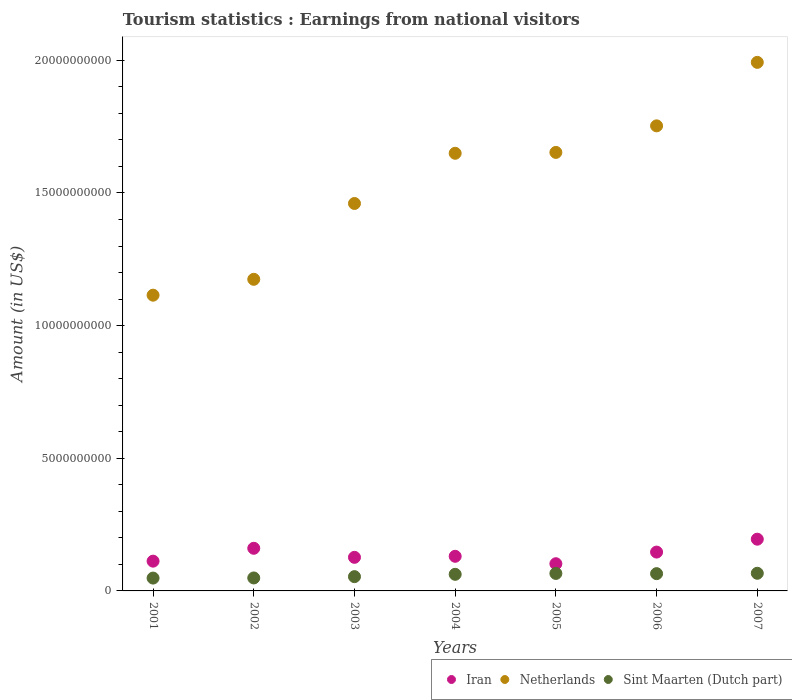How many different coloured dotlines are there?
Offer a terse response. 3. Is the number of dotlines equal to the number of legend labels?
Offer a very short reply. Yes. What is the earnings from national visitors in Iran in 2006?
Keep it short and to the point. 1.46e+09. Across all years, what is the maximum earnings from national visitors in Netherlands?
Ensure brevity in your answer.  1.99e+1. Across all years, what is the minimum earnings from national visitors in Iran?
Offer a terse response. 1.02e+09. What is the total earnings from national visitors in Netherlands in the graph?
Ensure brevity in your answer.  1.08e+11. What is the difference between the earnings from national visitors in Iran in 2001 and that in 2003?
Give a very brief answer. -1.44e+08. What is the difference between the earnings from national visitors in Sint Maarten (Dutch part) in 2005 and the earnings from national visitors in Iran in 2001?
Your answer should be very brief. -4.63e+08. What is the average earnings from national visitors in Netherlands per year?
Provide a succinct answer. 1.54e+1. In the year 2005, what is the difference between the earnings from national visitors in Sint Maarten (Dutch part) and earnings from national visitors in Iran?
Your answer should be very brief. -3.66e+08. In how many years, is the earnings from national visitors in Sint Maarten (Dutch part) greater than 5000000000 US$?
Offer a terse response. 0. What is the ratio of the earnings from national visitors in Sint Maarten (Dutch part) in 2006 to that in 2007?
Make the answer very short. 0.98. Is the earnings from national visitors in Netherlands in 2003 less than that in 2007?
Ensure brevity in your answer.  Yes. What is the difference between the highest and the lowest earnings from national visitors in Iran?
Ensure brevity in your answer.  9.25e+08. In how many years, is the earnings from national visitors in Iran greater than the average earnings from national visitors in Iran taken over all years?
Offer a very short reply. 3. Is it the case that in every year, the sum of the earnings from national visitors in Sint Maarten (Dutch part) and earnings from national visitors in Netherlands  is greater than the earnings from national visitors in Iran?
Your answer should be very brief. Yes. Does the earnings from national visitors in Sint Maarten (Dutch part) monotonically increase over the years?
Keep it short and to the point. No. Is the earnings from national visitors in Iran strictly greater than the earnings from national visitors in Netherlands over the years?
Keep it short and to the point. No. Is the earnings from national visitors in Sint Maarten (Dutch part) strictly less than the earnings from national visitors in Iran over the years?
Your answer should be very brief. Yes. How many dotlines are there?
Give a very brief answer. 3. How many years are there in the graph?
Give a very brief answer. 7. What is the difference between two consecutive major ticks on the Y-axis?
Provide a short and direct response. 5.00e+09. Are the values on the major ticks of Y-axis written in scientific E-notation?
Your answer should be very brief. No. Does the graph contain any zero values?
Offer a terse response. No. Does the graph contain grids?
Ensure brevity in your answer.  No. How many legend labels are there?
Give a very brief answer. 3. How are the legend labels stacked?
Give a very brief answer. Horizontal. What is the title of the graph?
Offer a very short reply. Tourism statistics : Earnings from national visitors. What is the label or title of the X-axis?
Your answer should be compact. Years. What is the Amount (in US$) in Iran in 2001?
Your response must be concise. 1.12e+09. What is the Amount (in US$) of Netherlands in 2001?
Your answer should be very brief. 1.11e+1. What is the Amount (in US$) in Sint Maarten (Dutch part) in 2001?
Your answer should be very brief. 4.84e+08. What is the Amount (in US$) in Iran in 2002?
Offer a very short reply. 1.61e+09. What is the Amount (in US$) in Netherlands in 2002?
Your answer should be compact. 1.17e+1. What is the Amount (in US$) of Sint Maarten (Dutch part) in 2002?
Your response must be concise. 4.89e+08. What is the Amount (in US$) of Iran in 2003?
Offer a terse response. 1.27e+09. What is the Amount (in US$) in Netherlands in 2003?
Give a very brief answer. 1.46e+1. What is the Amount (in US$) in Sint Maarten (Dutch part) in 2003?
Make the answer very short. 5.38e+08. What is the Amount (in US$) of Iran in 2004?
Your response must be concise. 1.30e+09. What is the Amount (in US$) in Netherlands in 2004?
Your response must be concise. 1.65e+1. What is the Amount (in US$) in Sint Maarten (Dutch part) in 2004?
Your response must be concise. 6.26e+08. What is the Amount (in US$) of Iran in 2005?
Keep it short and to the point. 1.02e+09. What is the Amount (in US$) of Netherlands in 2005?
Your response must be concise. 1.65e+1. What is the Amount (in US$) of Sint Maarten (Dutch part) in 2005?
Your answer should be very brief. 6.59e+08. What is the Amount (in US$) in Iran in 2006?
Ensure brevity in your answer.  1.46e+09. What is the Amount (in US$) in Netherlands in 2006?
Keep it short and to the point. 1.75e+1. What is the Amount (in US$) of Sint Maarten (Dutch part) in 2006?
Give a very brief answer. 6.51e+08. What is the Amount (in US$) in Iran in 2007?
Your answer should be compact. 1.95e+09. What is the Amount (in US$) of Netherlands in 2007?
Your answer should be compact. 1.99e+1. What is the Amount (in US$) of Sint Maarten (Dutch part) in 2007?
Keep it short and to the point. 6.65e+08. Across all years, what is the maximum Amount (in US$) of Iran?
Ensure brevity in your answer.  1.95e+09. Across all years, what is the maximum Amount (in US$) in Netherlands?
Your response must be concise. 1.99e+1. Across all years, what is the maximum Amount (in US$) of Sint Maarten (Dutch part)?
Keep it short and to the point. 6.65e+08. Across all years, what is the minimum Amount (in US$) of Iran?
Your response must be concise. 1.02e+09. Across all years, what is the minimum Amount (in US$) in Netherlands?
Make the answer very short. 1.11e+1. Across all years, what is the minimum Amount (in US$) of Sint Maarten (Dutch part)?
Keep it short and to the point. 4.84e+08. What is the total Amount (in US$) of Iran in the graph?
Give a very brief answer. 9.74e+09. What is the total Amount (in US$) in Netherlands in the graph?
Give a very brief answer. 1.08e+11. What is the total Amount (in US$) of Sint Maarten (Dutch part) in the graph?
Offer a terse response. 4.11e+09. What is the difference between the Amount (in US$) of Iran in 2001 and that in 2002?
Make the answer very short. -4.85e+08. What is the difference between the Amount (in US$) of Netherlands in 2001 and that in 2002?
Your answer should be very brief. -5.98e+08. What is the difference between the Amount (in US$) of Sint Maarten (Dutch part) in 2001 and that in 2002?
Keep it short and to the point. -5.00e+06. What is the difference between the Amount (in US$) of Iran in 2001 and that in 2003?
Give a very brief answer. -1.44e+08. What is the difference between the Amount (in US$) of Netherlands in 2001 and that in 2003?
Offer a very short reply. -3.46e+09. What is the difference between the Amount (in US$) in Sint Maarten (Dutch part) in 2001 and that in 2003?
Make the answer very short. -5.40e+07. What is the difference between the Amount (in US$) of Iran in 2001 and that in 2004?
Your response must be concise. -1.83e+08. What is the difference between the Amount (in US$) in Netherlands in 2001 and that in 2004?
Your answer should be very brief. -5.35e+09. What is the difference between the Amount (in US$) in Sint Maarten (Dutch part) in 2001 and that in 2004?
Make the answer very short. -1.42e+08. What is the difference between the Amount (in US$) of Iran in 2001 and that in 2005?
Offer a terse response. 9.70e+07. What is the difference between the Amount (in US$) in Netherlands in 2001 and that in 2005?
Your answer should be very brief. -5.38e+09. What is the difference between the Amount (in US$) of Sint Maarten (Dutch part) in 2001 and that in 2005?
Provide a succinct answer. -1.75e+08. What is the difference between the Amount (in US$) of Iran in 2001 and that in 2006?
Offer a very short reply. -3.42e+08. What is the difference between the Amount (in US$) of Netherlands in 2001 and that in 2006?
Your answer should be very brief. -6.38e+09. What is the difference between the Amount (in US$) in Sint Maarten (Dutch part) in 2001 and that in 2006?
Your answer should be very brief. -1.67e+08. What is the difference between the Amount (in US$) of Iran in 2001 and that in 2007?
Ensure brevity in your answer.  -8.28e+08. What is the difference between the Amount (in US$) in Netherlands in 2001 and that in 2007?
Your answer should be very brief. -8.78e+09. What is the difference between the Amount (in US$) of Sint Maarten (Dutch part) in 2001 and that in 2007?
Provide a succinct answer. -1.81e+08. What is the difference between the Amount (in US$) in Iran in 2002 and that in 2003?
Provide a short and direct response. 3.41e+08. What is the difference between the Amount (in US$) of Netherlands in 2002 and that in 2003?
Offer a terse response. -2.86e+09. What is the difference between the Amount (in US$) of Sint Maarten (Dutch part) in 2002 and that in 2003?
Your answer should be very brief. -4.90e+07. What is the difference between the Amount (in US$) of Iran in 2002 and that in 2004?
Your answer should be very brief. 3.02e+08. What is the difference between the Amount (in US$) in Netherlands in 2002 and that in 2004?
Make the answer very short. -4.75e+09. What is the difference between the Amount (in US$) of Sint Maarten (Dutch part) in 2002 and that in 2004?
Your answer should be compact. -1.37e+08. What is the difference between the Amount (in US$) of Iran in 2002 and that in 2005?
Provide a short and direct response. 5.82e+08. What is the difference between the Amount (in US$) in Netherlands in 2002 and that in 2005?
Provide a short and direct response. -4.78e+09. What is the difference between the Amount (in US$) in Sint Maarten (Dutch part) in 2002 and that in 2005?
Your answer should be very brief. -1.70e+08. What is the difference between the Amount (in US$) of Iran in 2002 and that in 2006?
Provide a short and direct response. 1.43e+08. What is the difference between the Amount (in US$) in Netherlands in 2002 and that in 2006?
Ensure brevity in your answer.  -5.78e+09. What is the difference between the Amount (in US$) in Sint Maarten (Dutch part) in 2002 and that in 2006?
Your answer should be compact. -1.62e+08. What is the difference between the Amount (in US$) in Iran in 2002 and that in 2007?
Keep it short and to the point. -3.43e+08. What is the difference between the Amount (in US$) in Netherlands in 2002 and that in 2007?
Ensure brevity in your answer.  -8.18e+09. What is the difference between the Amount (in US$) of Sint Maarten (Dutch part) in 2002 and that in 2007?
Offer a terse response. -1.76e+08. What is the difference between the Amount (in US$) in Iran in 2003 and that in 2004?
Offer a very short reply. -3.90e+07. What is the difference between the Amount (in US$) in Netherlands in 2003 and that in 2004?
Give a very brief answer. -1.89e+09. What is the difference between the Amount (in US$) in Sint Maarten (Dutch part) in 2003 and that in 2004?
Keep it short and to the point. -8.80e+07. What is the difference between the Amount (in US$) of Iran in 2003 and that in 2005?
Your answer should be very brief. 2.41e+08. What is the difference between the Amount (in US$) of Netherlands in 2003 and that in 2005?
Make the answer very short. -1.92e+09. What is the difference between the Amount (in US$) of Sint Maarten (Dutch part) in 2003 and that in 2005?
Provide a succinct answer. -1.21e+08. What is the difference between the Amount (in US$) in Iran in 2003 and that in 2006?
Your response must be concise. -1.98e+08. What is the difference between the Amount (in US$) in Netherlands in 2003 and that in 2006?
Provide a succinct answer. -2.93e+09. What is the difference between the Amount (in US$) of Sint Maarten (Dutch part) in 2003 and that in 2006?
Give a very brief answer. -1.13e+08. What is the difference between the Amount (in US$) of Iran in 2003 and that in 2007?
Your answer should be compact. -6.84e+08. What is the difference between the Amount (in US$) of Netherlands in 2003 and that in 2007?
Your answer should be very brief. -5.32e+09. What is the difference between the Amount (in US$) of Sint Maarten (Dutch part) in 2003 and that in 2007?
Offer a very short reply. -1.27e+08. What is the difference between the Amount (in US$) of Iran in 2004 and that in 2005?
Your answer should be compact. 2.80e+08. What is the difference between the Amount (in US$) in Netherlands in 2004 and that in 2005?
Make the answer very short. -3.30e+07. What is the difference between the Amount (in US$) in Sint Maarten (Dutch part) in 2004 and that in 2005?
Your response must be concise. -3.30e+07. What is the difference between the Amount (in US$) in Iran in 2004 and that in 2006?
Your response must be concise. -1.59e+08. What is the difference between the Amount (in US$) of Netherlands in 2004 and that in 2006?
Ensure brevity in your answer.  -1.03e+09. What is the difference between the Amount (in US$) of Sint Maarten (Dutch part) in 2004 and that in 2006?
Offer a terse response. -2.50e+07. What is the difference between the Amount (in US$) of Iran in 2004 and that in 2007?
Your answer should be very brief. -6.45e+08. What is the difference between the Amount (in US$) in Netherlands in 2004 and that in 2007?
Offer a very short reply. -3.43e+09. What is the difference between the Amount (in US$) in Sint Maarten (Dutch part) in 2004 and that in 2007?
Make the answer very short. -3.90e+07. What is the difference between the Amount (in US$) of Iran in 2005 and that in 2006?
Offer a very short reply. -4.39e+08. What is the difference between the Amount (in US$) in Netherlands in 2005 and that in 2006?
Your answer should be compact. -1.00e+09. What is the difference between the Amount (in US$) of Iran in 2005 and that in 2007?
Keep it short and to the point. -9.25e+08. What is the difference between the Amount (in US$) of Netherlands in 2005 and that in 2007?
Provide a short and direct response. -3.39e+09. What is the difference between the Amount (in US$) in Sint Maarten (Dutch part) in 2005 and that in 2007?
Your response must be concise. -6.00e+06. What is the difference between the Amount (in US$) in Iran in 2006 and that in 2007?
Provide a short and direct response. -4.86e+08. What is the difference between the Amount (in US$) of Netherlands in 2006 and that in 2007?
Make the answer very short. -2.39e+09. What is the difference between the Amount (in US$) in Sint Maarten (Dutch part) in 2006 and that in 2007?
Ensure brevity in your answer.  -1.40e+07. What is the difference between the Amount (in US$) of Iran in 2001 and the Amount (in US$) of Netherlands in 2002?
Provide a short and direct response. -1.06e+1. What is the difference between the Amount (in US$) in Iran in 2001 and the Amount (in US$) in Sint Maarten (Dutch part) in 2002?
Offer a terse response. 6.33e+08. What is the difference between the Amount (in US$) of Netherlands in 2001 and the Amount (in US$) of Sint Maarten (Dutch part) in 2002?
Offer a terse response. 1.07e+1. What is the difference between the Amount (in US$) of Iran in 2001 and the Amount (in US$) of Netherlands in 2003?
Your answer should be compact. -1.35e+1. What is the difference between the Amount (in US$) of Iran in 2001 and the Amount (in US$) of Sint Maarten (Dutch part) in 2003?
Offer a terse response. 5.84e+08. What is the difference between the Amount (in US$) of Netherlands in 2001 and the Amount (in US$) of Sint Maarten (Dutch part) in 2003?
Provide a succinct answer. 1.06e+1. What is the difference between the Amount (in US$) of Iran in 2001 and the Amount (in US$) of Netherlands in 2004?
Offer a terse response. -1.54e+1. What is the difference between the Amount (in US$) in Iran in 2001 and the Amount (in US$) in Sint Maarten (Dutch part) in 2004?
Provide a succinct answer. 4.96e+08. What is the difference between the Amount (in US$) in Netherlands in 2001 and the Amount (in US$) in Sint Maarten (Dutch part) in 2004?
Give a very brief answer. 1.05e+1. What is the difference between the Amount (in US$) in Iran in 2001 and the Amount (in US$) in Netherlands in 2005?
Keep it short and to the point. -1.54e+1. What is the difference between the Amount (in US$) of Iran in 2001 and the Amount (in US$) of Sint Maarten (Dutch part) in 2005?
Ensure brevity in your answer.  4.63e+08. What is the difference between the Amount (in US$) in Netherlands in 2001 and the Amount (in US$) in Sint Maarten (Dutch part) in 2005?
Your answer should be very brief. 1.05e+1. What is the difference between the Amount (in US$) in Iran in 2001 and the Amount (in US$) in Netherlands in 2006?
Your response must be concise. -1.64e+1. What is the difference between the Amount (in US$) in Iran in 2001 and the Amount (in US$) in Sint Maarten (Dutch part) in 2006?
Offer a terse response. 4.71e+08. What is the difference between the Amount (in US$) of Netherlands in 2001 and the Amount (in US$) of Sint Maarten (Dutch part) in 2006?
Provide a short and direct response. 1.05e+1. What is the difference between the Amount (in US$) of Iran in 2001 and the Amount (in US$) of Netherlands in 2007?
Your response must be concise. -1.88e+1. What is the difference between the Amount (in US$) in Iran in 2001 and the Amount (in US$) in Sint Maarten (Dutch part) in 2007?
Your response must be concise. 4.57e+08. What is the difference between the Amount (in US$) of Netherlands in 2001 and the Amount (in US$) of Sint Maarten (Dutch part) in 2007?
Offer a terse response. 1.05e+1. What is the difference between the Amount (in US$) of Iran in 2002 and the Amount (in US$) of Netherlands in 2003?
Provide a short and direct response. -1.30e+1. What is the difference between the Amount (in US$) in Iran in 2002 and the Amount (in US$) in Sint Maarten (Dutch part) in 2003?
Offer a very short reply. 1.07e+09. What is the difference between the Amount (in US$) in Netherlands in 2002 and the Amount (in US$) in Sint Maarten (Dutch part) in 2003?
Ensure brevity in your answer.  1.12e+1. What is the difference between the Amount (in US$) of Iran in 2002 and the Amount (in US$) of Netherlands in 2004?
Your answer should be very brief. -1.49e+1. What is the difference between the Amount (in US$) in Iran in 2002 and the Amount (in US$) in Sint Maarten (Dutch part) in 2004?
Give a very brief answer. 9.81e+08. What is the difference between the Amount (in US$) in Netherlands in 2002 and the Amount (in US$) in Sint Maarten (Dutch part) in 2004?
Ensure brevity in your answer.  1.11e+1. What is the difference between the Amount (in US$) in Iran in 2002 and the Amount (in US$) in Netherlands in 2005?
Provide a short and direct response. -1.49e+1. What is the difference between the Amount (in US$) in Iran in 2002 and the Amount (in US$) in Sint Maarten (Dutch part) in 2005?
Your answer should be very brief. 9.48e+08. What is the difference between the Amount (in US$) of Netherlands in 2002 and the Amount (in US$) of Sint Maarten (Dutch part) in 2005?
Your answer should be very brief. 1.11e+1. What is the difference between the Amount (in US$) of Iran in 2002 and the Amount (in US$) of Netherlands in 2006?
Offer a terse response. -1.59e+1. What is the difference between the Amount (in US$) in Iran in 2002 and the Amount (in US$) in Sint Maarten (Dutch part) in 2006?
Keep it short and to the point. 9.56e+08. What is the difference between the Amount (in US$) in Netherlands in 2002 and the Amount (in US$) in Sint Maarten (Dutch part) in 2006?
Offer a very short reply. 1.11e+1. What is the difference between the Amount (in US$) of Iran in 2002 and the Amount (in US$) of Netherlands in 2007?
Your answer should be compact. -1.83e+1. What is the difference between the Amount (in US$) in Iran in 2002 and the Amount (in US$) in Sint Maarten (Dutch part) in 2007?
Your answer should be compact. 9.42e+08. What is the difference between the Amount (in US$) of Netherlands in 2002 and the Amount (in US$) of Sint Maarten (Dutch part) in 2007?
Offer a terse response. 1.11e+1. What is the difference between the Amount (in US$) of Iran in 2003 and the Amount (in US$) of Netherlands in 2004?
Your answer should be very brief. -1.52e+1. What is the difference between the Amount (in US$) in Iran in 2003 and the Amount (in US$) in Sint Maarten (Dutch part) in 2004?
Your response must be concise. 6.40e+08. What is the difference between the Amount (in US$) of Netherlands in 2003 and the Amount (in US$) of Sint Maarten (Dutch part) in 2004?
Make the answer very short. 1.40e+1. What is the difference between the Amount (in US$) of Iran in 2003 and the Amount (in US$) of Netherlands in 2005?
Provide a short and direct response. -1.53e+1. What is the difference between the Amount (in US$) in Iran in 2003 and the Amount (in US$) in Sint Maarten (Dutch part) in 2005?
Your answer should be very brief. 6.07e+08. What is the difference between the Amount (in US$) of Netherlands in 2003 and the Amount (in US$) of Sint Maarten (Dutch part) in 2005?
Your response must be concise. 1.39e+1. What is the difference between the Amount (in US$) of Iran in 2003 and the Amount (in US$) of Netherlands in 2006?
Your answer should be compact. -1.63e+1. What is the difference between the Amount (in US$) in Iran in 2003 and the Amount (in US$) in Sint Maarten (Dutch part) in 2006?
Your answer should be very brief. 6.15e+08. What is the difference between the Amount (in US$) in Netherlands in 2003 and the Amount (in US$) in Sint Maarten (Dutch part) in 2006?
Offer a very short reply. 1.40e+1. What is the difference between the Amount (in US$) of Iran in 2003 and the Amount (in US$) of Netherlands in 2007?
Make the answer very short. -1.87e+1. What is the difference between the Amount (in US$) of Iran in 2003 and the Amount (in US$) of Sint Maarten (Dutch part) in 2007?
Give a very brief answer. 6.01e+08. What is the difference between the Amount (in US$) in Netherlands in 2003 and the Amount (in US$) in Sint Maarten (Dutch part) in 2007?
Give a very brief answer. 1.39e+1. What is the difference between the Amount (in US$) in Iran in 2004 and the Amount (in US$) in Netherlands in 2005?
Your answer should be very brief. -1.52e+1. What is the difference between the Amount (in US$) of Iran in 2004 and the Amount (in US$) of Sint Maarten (Dutch part) in 2005?
Provide a succinct answer. 6.46e+08. What is the difference between the Amount (in US$) in Netherlands in 2004 and the Amount (in US$) in Sint Maarten (Dutch part) in 2005?
Your answer should be compact. 1.58e+1. What is the difference between the Amount (in US$) of Iran in 2004 and the Amount (in US$) of Netherlands in 2006?
Your answer should be compact. -1.62e+1. What is the difference between the Amount (in US$) of Iran in 2004 and the Amount (in US$) of Sint Maarten (Dutch part) in 2006?
Offer a very short reply. 6.54e+08. What is the difference between the Amount (in US$) in Netherlands in 2004 and the Amount (in US$) in Sint Maarten (Dutch part) in 2006?
Offer a very short reply. 1.58e+1. What is the difference between the Amount (in US$) of Iran in 2004 and the Amount (in US$) of Netherlands in 2007?
Make the answer very short. -1.86e+1. What is the difference between the Amount (in US$) of Iran in 2004 and the Amount (in US$) of Sint Maarten (Dutch part) in 2007?
Keep it short and to the point. 6.40e+08. What is the difference between the Amount (in US$) in Netherlands in 2004 and the Amount (in US$) in Sint Maarten (Dutch part) in 2007?
Provide a succinct answer. 1.58e+1. What is the difference between the Amount (in US$) in Iran in 2005 and the Amount (in US$) in Netherlands in 2006?
Provide a succinct answer. -1.65e+1. What is the difference between the Amount (in US$) of Iran in 2005 and the Amount (in US$) of Sint Maarten (Dutch part) in 2006?
Provide a succinct answer. 3.74e+08. What is the difference between the Amount (in US$) in Netherlands in 2005 and the Amount (in US$) in Sint Maarten (Dutch part) in 2006?
Keep it short and to the point. 1.59e+1. What is the difference between the Amount (in US$) of Iran in 2005 and the Amount (in US$) of Netherlands in 2007?
Provide a succinct answer. -1.89e+1. What is the difference between the Amount (in US$) in Iran in 2005 and the Amount (in US$) in Sint Maarten (Dutch part) in 2007?
Give a very brief answer. 3.60e+08. What is the difference between the Amount (in US$) of Netherlands in 2005 and the Amount (in US$) of Sint Maarten (Dutch part) in 2007?
Provide a short and direct response. 1.59e+1. What is the difference between the Amount (in US$) in Iran in 2006 and the Amount (in US$) in Netherlands in 2007?
Your response must be concise. -1.85e+1. What is the difference between the Amount (in US$) in Iran in 2006 and the Amount (in US$) in Sint Maarten (Dutch part) in 2007?
Offer a very short reply. 7.99e+08. What is the difference between the Amount (in US$) in Netherlands in 2006 and the Amount (in US$) in Sint Maarten (Dutch part) in 2007?
Ensure brevity in your answer.  1.69e+1. What is the average Amount (in US$) in Iran per year?
Your response must be concise. 1.39e+09. What is the average Amount (in US$) of Netherlands per year?
Ensure brevity in your answer.  1.54e+1. What is the average Amount (in US$) of Sint Maarten (Dutch part) per year?
Your response must be concise. 5.87e+08. In the year 2001, what is the difference between the Amount (in US$) of Iran and Amount (in US$) of Netherlands?
Your answer should be compact. -1.00e+1. In the year 2001, what is the difference between the Amount (in US$) of Iran and Amount (in US$) of Sint Maarten (Dutch part)?
Make the answer very short. 6.38e+08. In the year 2001, what is the difference between the Amount (in US$) of Netherlands and Amount (in US$) of Sint Maarten (Dutch part)?
Keep it short and to the point. 1.07e+1. In the year 2002, what is the difference between the Amount (in US$) of Iran and Amount (in US$) of Netherlands?
Offer a terse response. -1.01e+1. In the year 2002, what is the difference between the Amount (in US$) in Iran and Amount (in US$) in Sint Maarten (Dutch part)?
Ensure brevity in your answer.  1.12e+09. In the year 2002, what is the difference between the Amount (in US$) in Netherlands and Amount (in US$) in Sint Maarten (Dutch part)?
Ensure brevity in your answer.  1.13e+1. In the year 2003, what is the difference between the Amount (in US$) in Iran and Amount (in US$) in Netherlands?
Your response must be concise. -1.33e+1. In the year 2003, what is the difference between the Amount (in US$) in Iran and Amount (in US$) in Sint Maarten (Dutch part)?
Provide a short and direct response. 7.28e+08. In the year 2003, what is the difference between the Amount (in US$) of Netherlands and Amount (in US$) of Sint Maarten (Dutch part)?
Your response must be concise. 1.41e+1. In the year 2004, what is the difference between the Amount (in US$) in Iran and Amount (in US$) in Netherlands?
Give a very brief answer. -1.52e+1. In the year 2004, what is the difference between the Amount (in US$) of Iran and Amount (in US$) of Sint Maarten (Dutch part)?
Your answer should be compact. 6.79e+08. In the year 2004, what is the difference between the Amount (in US$) of Netherlands and Amount (in US$) of Sint Maarten (Dutch part)?
Your response must be concise. 1.59e+1. In the year 2005, what is the difference between the Amount (in US$) in Iran and Amount (in US$) in Netherlands?
Make the answer very short. -1.55e+1. In the year 2005, what is the difference between the Amount (in US$) of Iran and Amount (in US$) of Sint Maarten (Dutch part)?
Your response must be concise. 3.66e+08. In the year 2005, what is the difference between the Amount (in US$) in Netherlands and Amount (in US$) in Sint Maarten (Dutch part)?
Offer a terse response. 1.59e+1. In the year 2006, what is the difference between the Amount (in US$) in Iran and Amount (in US$) in Netherlands?
Keep it short and to the point. -1.61e+1. In the year 2006, what is the difference between the Amount (in US$) of Iran and Amount (in US$) of Sint Maarten (Dutch part)?
Provide a short and direct response. 8.13e+08. In the year 2006, what is the difference between the Amount (in US$) of Netherlands and Amount (in US$) of Sint Maarten (Dutch part)?
Your answer should be very brief. 1.69e+1. In the year 2007, what is the difference between the Amount (in US$) of Iran and Amount (in US$) of Netherlands?
Offer a very short reply. -1.80e+1. In the year 2007, what is the difference between the Amount (in US$) of Iran and Amount (in US$) of Sint Maarten (Dutch part)?
Your answer should be compact. 1.28e+09. In the year 2007, what is the difference between the Amount (in US$) in Netherlands and Amount (in US$) in Sint Maarten (Dutch part)?
Your response must be concise. 1.93e+1. What is the ratio of the Amount (in US$) in Iran in 2001 to that in 2002?
Your answer should be compact. 0.7. What is the ratio of the Amount (in US$) of Netherlands in 2001 to that in 2002?
Give a very brief answer. 0.95. What is the ratio of the Amount (in US$) of Sint Maarten (Dutch part) in 2001 to that in 2002?
Offer a very short reply. 0.99. What is the ratio of the Amount (in US$) in Iran in 2001 to that in 2003?
Your response must be concise. 0.89. What is the ratio of the Amount (in US$) of Netherlands in 2001 to that in 2003?
Provide a short and direct response. 0.76. What is the ratio of the Amount (in US$) in Sint Maarten (Dutch part) in 2001 to that in 2003?
Your answer should be compact. 0.9. What is the ratio of the Amount (in US$) of Iran in 2001 to that in 2004?
Give a very brief answer. 0.86. What is the ratio of the Amount (in US$) in Netherlands in 2001 to that in 2004?
Your answer should be very brief. 0.68. What is the ratio of the Amount (in US$) in Sint Maarten (Dutch part) in 2001 to that in 2004?
Your answer should be compact. 0.77. What is the ratio of the Amount (in US$) in Iran in 2001 to that in 2005?
Make the answer very short. 1.09. What is the ratio of the Amount (in US$) in Netherlands in 2001 to that in 2005?
Provide a short and direct response. 0.67. What is the ratio of the Amount (in US$) of Sint Maarten (Dutch part) in 2001 to that in 2005?
Your answer should be very brief. 0.73. What is the ratio of the Amount (in US$) of Iran in 2001 to that in 2006?
Give a very brief answer. 0.77. What is the ratio of the Amount (in US$) of Netherlands in 2001 to that in 2006?
Make the answer very short. 0.64. What is the ratio of the Amount (in US$) in Sint Maarten (Dutch part) in 2001 to that in 2006?
Make the answer very short. 0.74. What is the ratio of the Amount (in US$) of Iran in 2001 to that in 2007?
Make the answer very short. 0.58. What is the ratio of the Amount (in US$) in Netherlands in 2001 to that in 2007?
Make the answer very short. 0.56. What is the ratio of the Amount (in US$) in Sint Maarten (Dutch part) in 2001 to that in 2007?
Offer a terse response. 0.73. What is the ratio of the Amount (in US$) in Iran in 2002 to that in 2003?
Your response must be concise. 1.27. What is the ratio of the Amount (in US$) in Netherlands in 2002 to that in 2003?
Keep it short and to the point. 0.8. What is the ratio of the Amount (in US$) in Sint Maarten (Dutch part) in 2002 to that in 2003?
Provide a short and direct response. 0.91. What is the ratio of the Amount (in US$) of Iran in 2002 to that in 2004?
Ensure brevity in your answer.  1.23. What is the ratio of the Amount (in US$) in Netherlands in 2002 to that in 2004?
Provide a succinct answer. 0.71. What is the ratio of the Amount (in US$) in Sint Maarten (Dutch part) in 2002 to that in 2004?
Give a very brief answer. 0.78. What is the ratio of the Amount (in US$) in Iran in 2002 to that in 2005?
Your answer should be compact. 1.57. What is the ratio of the Amount (in US$) in Netherlands in 2002 to that in 2005?
Your answer should be very brief. 0.71. What is the ratio of the Amount (in US$) of Sint Maarten (Dutch part) in 2002 to that in 2005?
Offer a terse response. 0.74. What is the ratio of the Amount (in US$) in Iran in 2002 to that in 2006?
Make the answer very short. 1.1. What is the ratio of the Amount (in US$) in Netherlands in 2002 to that in 2006?
Offer a very short reply. 0.67. What is the ratio of the Amount (in US$) in Sint Maarten (Dutch part) in 2002 to that in 2006?
Your answer should be compact. 0.75. What is the ratio of the Amount (in US$) of Iran in 2002 to that in 2007?
Your answer should be very brief. 0.82. What is the ratio of the Amount (in US$) of Netherlands in 2002 to that in 2007?
Ensure brevity in your answer.  0.59. What is the ratio of the Amount (in US$) in Sint Maarten (Dutch part) in 2002 to that in 2007?
Give a very brief answer. 0.74. What is the ratio of the Amount (in US$) in Iran in 2003 to that in 2004?
Provide a short and direct response. 0.97. What is the ratio of the Amount (in US$) in Netherlands in 2003 to that in 2004?
Offer a very short reply. 0.89. What is the ratio of the Amount (in US$) in Sint Maarten (Dutch part) in 2003 to that in 2004?
Your answer should be compact. 0.86. What is the ratio of the Amount (in US$) in Iran in 2003 to that in 2005?
Offer a very short reply. 1.24. What is the ratio of the Amount (in US$) of Netherlands in 2003 to that in 2005?
Provide a short and direct response. 0.88. What is the ratio of the Amount (in US$) of Sint Maarten (Dutch part) in 2003 to that in 2005?
Your answer should be very brief. 0.82. What is the ratio of the Amount (in US$) of Iran in 2003 to that in 2006?
Your response must be concise. 0.86. What is the ratio of the Amount (in US$) in Netherlands in 2003 to that in 2006?
Offer a very short reply. 0.83. What is the ratio of the Amount (in US$) in Sint Maarten (Dutch part) in 2003 to that in 2006?
Offer a very short reply. 0.83. What is the ratio of the Amount (in US$) of Iran in 2003 to that in 2007?
Provide a succinct answer. 0.65. What is the ratio of the Amount (in US$) in Netherlands in 2003 to that in 2007?
Your answer should be compact. 0.73. What is the ratio of the Amount (in US$) in Sint Maarten (Dutch part) in 2003 to that in 2007?
Your answer should be very brief. 0.81. What is the ratio of the Amount (in US$) in Iran in 2004 to that in 2005?
Offer a very short reply. 1.27. What is the ratio of the Amount (in US$) of Netherlands in 2004 to that in 2005?
Your answer should be compact. 1. What is the ratio of the Amount (in US$) in Sint Maarten (Dutch part) in 2004 to that in 2005?
Give a very brief answer. 0.95. What is the ratio of the Amount (in US$) in Iran in 2004 to that in 2006?
Keep it short and to the point. 0.89. What is the ratio of the Amount (in US$) of Netherlands in 2004 to that in 2006?
Provide a succinct answer. 0.94. What is the ratio of the Amount (in US$) of Sint Maarten (Dutch part) in 2004 to that in 2006?
Keep it short and to the point. 0.96. What is the ratio of the Amount (in US$) in Iran in 2004 to that in 2007?
Ensure brevity in your answer.  0.67. What is the ratio of the Amount (in US$) in Netherlands in 2004 to that in 2007?
Your answer should be compact. 0.83. What is the ratio of the Amount (in US$) in Sint Maarten (Dutch part) in 2004 to that in 2007?
Provide a short and direct response. 0.94. What is the ratio of the Amount (in US$) of Iran in 2005 to that in 2006?
Make the answer very short. 0.7. What is the ratio of the Amount (in US$) in Netherlands in 2005 to that in 2006?
Provide a short and direct response. 0.94. What is the ratio of the Amount (in US$) in Sint Maarten (Dutch part) in 2005 to that in 2006?
Ensure brevity in your answer.  1.01. What is the ratio of the Amount (in US$) in Iran in 2005 to that in 2007?
Offer a very short reply. 0.53. What is the ratio of the Amount (in US$) of Netherlands in 2005 to that in 2007?
Your answer should be compact. 0.83. What is the ratio of the Amount (in US$) of Sint Maarten (Dutch part) in 2005 to that in 2007?
Provide a succinct answer. 0.99. What is the ratio of the Amount (in US$) of Iran in 2006 to that in 2007?
Give a very brief answer. 0.75. What is the ratio of the Amount (in US$) of Netherlands in 2006 to that in 2007?
Give a very brief answer. 0.88. What is the ratio of the Amount (in US$) in Sint Maarten (Dutch part) in 2006 to that in 2007?
Your answer should be compact. 0.98. What is the difference between the highest and the second highest Amount (in US$) of Iran?
Your answer should be compact. 3.43e+08. What is the difference between the highest and the second highest Amount (in US$) in Netherlands?
Offer a terse response. 2.39e+09. What is the difference between the highest and the second highest Amount (in US$) in Sint Maarten (Dutch part)?
Offer a very short reply. 6.00e+06. What is the difference between the highest and the lowest Amount (in US$) in Iran?
Offer a very short reply. 9.25e+08. What is the difference between the highest and the lowest Amount (in US$) in Netherlands?
Provide a succinct answer. 8.78e+09. What is the difference between the highest and the lowest Amount (in US$) of Sint Maarten (Dutch part)?
Make the answer very short. 1.81e+08. 